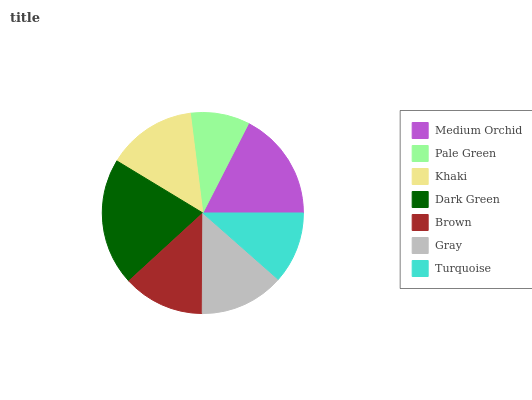Is Pale Green the minimum?
Answer yes or no. Yes. Is Dark Green the maximum?
Answer yes or no. Yes. Is Khaki the minimum?
Answer yes or no. No. Is Khaki the maximum?
Answer yes or no. No. Is Khaki greater than Pale Green?
Answer yes or no. Yes. Is Pale Green less than Khaki?
Answer yes or no. Yes. Is Pale Green greater than Khaki?
Answer yes or no. No. Is Khaki less than Pale Green?
Answer yes or no. No. Is Gray the high median?
Answer yes or no. Yes. Is Gray the low median?
Answer yes or no. Yes. Is Dark Green the high median?
Answer yes or no. No. Is Brown the low median?
Answer yes or no. No. 